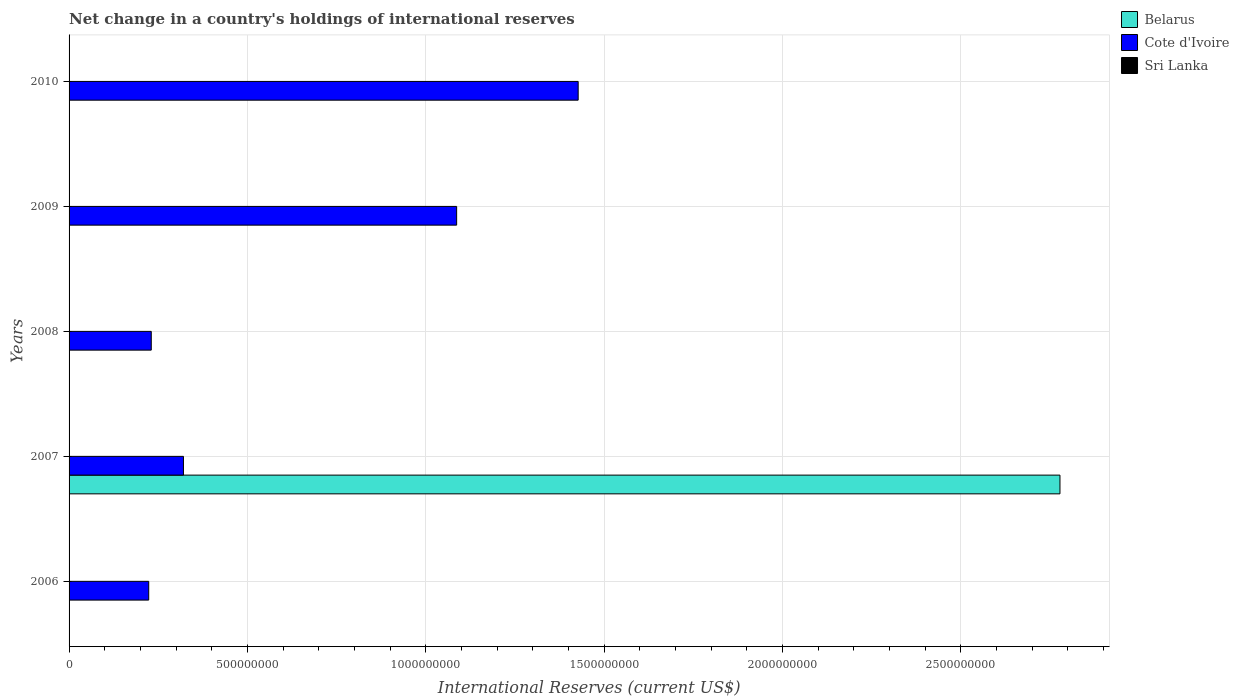Are the number of bars per tick equal to the number of legend labels?
Ensure brevity in your answer.  No. How many bars are there on the 2nd tick from the top?
Your answer should be very brief. 1. What is the label of the 1st group of bars from the top?
Give a very brief answer. 2010. In how many cases, is the number of bars for a given year not equal to the number of legend labels?
Keep it short and to the point. 5. What is the international reserves in Cote d'Ivoire in 2009?
Provide a short and direct response. 1.09e+09. Across all years, what is the maximum international reserves in Cote d'Ivoire?
Your answer should be compact. 1.43e+09. Across all years, what is the minimum international reserves in Cote d'Ivoire?
Offer a terse response. 2.23e+08. What is the total international reserves in Cote d'Ivoire in the graph?
Provide a succinct answer. 3.29e+09. What is the difference between the international reserves in Cote d'Ivoire in 2007 and that in 2008?
Offer a very short reply. 9.02e+07. What is the average international reserves in Sri Lanka per year?
Your answer should be compact. 0. In how many years, is the international reserves in Cote d'Ivoire greater than 400000000 US$?
Offer a terse response. 2. What is the ratio of the international reserves in Cote d'Ivoire in 2008 to that in 2009?
Keep it short and to the point. 0.21. Is the international reserves in Cote d'Ivoire in 2006 less than that in 2009?
Make the answer very short. Yes. What is the difference between the highest and the second highest international reserves in Cote d'Ivoire?
Ensure brevity in your answer.  3.41e+08. What is the difference between the highest and the lowest international reserves in Belarus?
Provide a succinct answer. 2.78e+09. Is the sum of the international reserves in Cote d'Ivoire in 2009 and 2010 greater than the maximum international reserves in Belarus across all years?
Give a very brief answer. No. Is it the case that in every year, the sum of the international reserves in Belarus and international reserves in Cote d'Ivoire is greater than the international reserves in Sri Lanka?
Offer a very short reply. Yes. What is the difference between two consecutive major ticks on the X-axis?
Provide a short and direct response. 5.00e+08. What is the title of the graph?
Offer a very short reply. Net change in a country's holdings of international reserves. What is the label or title of the X-axis?
Make the answer very short. International Reserves (current US$). What is the label or title of the Y-axis?
Provide a short and direct response. Years. What is the International Reserves (current US$) in Cote d'Ivoire in 2006?
Your response must be concise. 2.23e+08. What is the International Reserves (current US$) of Belarus in 2007?
Provide a short and direct response. 2.78e+09. What is the International Reserves (current US$) in Cote d'Ivoire in 2007?
Make the answer very short. 3.21e+08. What is the International Reserves (current US$) of Cote d'Ivoire in 2008?
Offer a very short reply. 2.30e+08. What is the International Reserves (current US$) in Cote d'Ivoire in 2009?
Offer a very short reply. 1.09e+09. What is the International Reserves (current US$) in Belarus in 2010?
Offer a very short reply. 0. What is the International Reserves (current US$) of Cote d'Ivoire in 2010?
Offer a terse response. 1.43e+09. What is the International Reserves (current US$) of Sri Lanka in 2010?
Offer a very short reply. 0. Across all years, what is the maximum International Reserves (current US$) of Belarus?
Provide a succinct answer. 2.78e+09. Across all years, what is the maximum International Reserves (current US$) in Cote d'Ivoire?
Your response must be concise. 1.43e+09. Across all years, what is the minimum International Reserves (current US$) of Belarus?
Your answer should be compact. 0. Across all years, what is the minimum International Reserves (current US$) of Cote d'Ivoire?
Offer a terse response. 2.23e+08. What is the total International Reserves (current US$) of Belarus in the graph?
Your response must be concise. 2.78e+09. What is the total International Reserves (current US$) of Cote d'Ivoire in the graph?
Provide a succinct answer. 3.29e+09. What is the total International Reserves (current US$) in Sri Lanka in the graph?
Provide a short and direct response. 0. What is the difference between the International Reserves (current US$) of Cote d'Ivoire in 2006 and that in 2007?
Provide a succinct answer. -9.74e+07. What is the difference between the International Reserves (current US$) of Cote d'Ivoire in 2006 and that in 2008?
Give a very brief answer. -7.15e+06. What is the difference between the International Reserves (current US$) of Cote d'Ivoire in 2006 and that in 2009?
Offer a terse response. -8.63e+08. What is the difference between the International Reserves (current US$) in Cote d'Ivoire in 2006 and that in 2010?
Your answer should be very brief. -1.20e+09. What is the difference between the International Reserves (current US$) of Cote d'Ivoire in 2007 and that in 2008?
Make the answer very short. 9.02e+07. What is the difference between the International Reserves (current US$) of Cote d'Ivoire in 2007 and that in 2009?
Offer a terse response. -7.66e+08. What is the difference between the International Reserves (current US$) of Cote d'Ivoire in 2007 and that in 2010?
Ensure brevity in your answer.  -1.11e+09. What is the difference between the International Reserves (current US$) of Cote d'Ivoire in 2008 and that in 2009?
Your answer should be compact. -8.56e+08. What is the difference between the International Reserves (current US$) of Cote d'Ivoire in 2008 and that in 2010?
Your response must be concise. -1.20e+09. What is the difference between the International Reserves (current US$) in Cote d'Ivoire in 2009 and that in 2010?
Offer a terse response. -3.41e+08. What is the difference between the International Reserves (current US$) in Belarus in 2007 and the International Reserves (current US$) in Cote d'Ivoire in 2008?
Provide a succinct answer. 2.55e+09. What is the difference between the International Reserves (current US$) in Belarus in 2007 and the International Reserves (current US$) in Cote d'Ivoire in 2009?
Make the answer very short. 1.69e+09. What is the difference between the International Reserves (current US$) of Belarus in 2007 and the International Reserves (current US$) of Cote d'Ivoire in 2010?
Give a very brief answer. 1.35e+09. What is the average International Reserves (current US$) in Belarus per year?
Provide a succinct answer. 5.56e+08. What is the average International Reserves (current US$) of Cote d'Ivoire per year?
Make the answer very short. 6.58e+08. What is the average International Reserves (current US$) of Sri Lanka per year?
Provide a succinct answer. 0. In the year 2007, what is the difference between the International Reserves (current US$) in Belarus and International Reserves (current US$) in Cote d'Ivoire?
Make the answer very short. 2.46e+09. What is the ratio of the International Reserves (current US$) of Cote d'Ivoire in 2006 to that in 2007?
Offer a terse response. 0.7. What is the ratio of the International Reserves (current US$) of Cote d'Ivoire in 2006 to that in 2009?
Your answer should be very brief. 0.21. What is the ratio of the International Reserves (current US$) of Cote d'Ivoire in 2006 to that in 2010?
Ensure brevity in your answer.  0.16. What is the ratio of the International Reserves (current US$) in Cote d'Ivoire in 2007 to that in 2008?
Offer a very short reply. 1.39. What is the ratio of the International Reserves (current US$) in Cote d'Ivoire in 2007 to that in 2009?
Offer a terse response. 0.3. What is the ratio of the International Reserves (current US$) in Cote d'Ivoire in 2007 to that in 2010?
Your answer should be very brief. 0.22. What is the ratio of the International Reserves (current US$) in Cote d'Ivoire in 2008 to that in 2009?
Your answer should be very brief. 0.21. What is the ratio of the International Reserves (current US$) in Cote d'Ivoire in 2008 to that in 2010?
Make the answer very short. 0.16. What is the ratio of the International Reserves (current US$) in Cote d'Ivoire in 2009 to that in 2010?
Offer a terse response. 0.76. What is the difference between the highest and the second highest International Reserves (current US$) in Cote d'Ivoire?
Provide a succinct answer. 3.41e+08. What is the difference between the highest and the lowest International Reserves (current US$) of Belarus?
Give a very brief answer. 2.78e+09. What is the difference between the highest and the lowest International Reserves (current US$) of Cote d'Ivoire?
Give a very brief answer. 1.20e+09. 